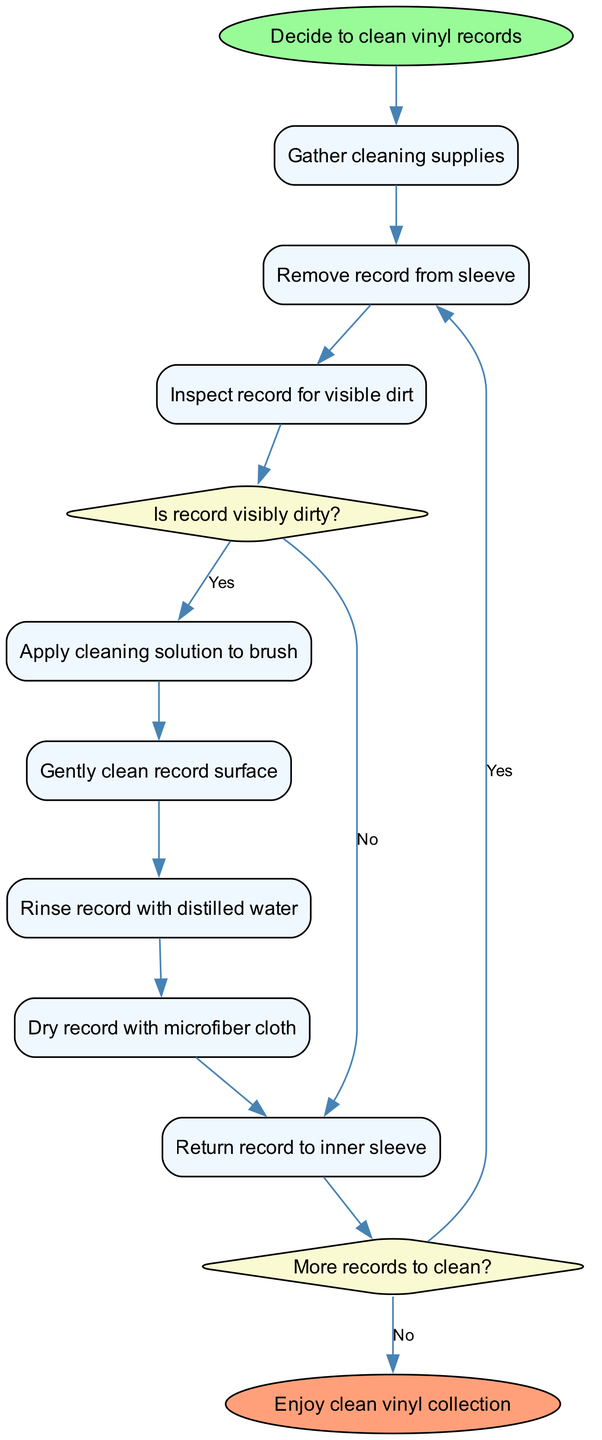What is the first activity in the diagram? The first node in the diagram lists "Gather cleaning supplies" as the initial activity after starting the cleaning process.
Answer: Gather cleaning supplies How many activities are there in total? Counting the listed activities, there are eight distinct activities depicted in the diagram, which includes both the cleaning and maintenance steps.
Answer: Eight What is the decision point related to visible dirt? The diagram highlights the condition "Is record visibly dirty?" as a decision point where actions diverge based on the presence of dirt on the record.
Answer: Is record visibly dirty? What action follows after noticing the record is not visibly dirty? According to the diagram, if the record is not visibly dirty, the next action is to "Return record to inner sleeve."
Answer: Return record to inner sleeve How do you proceed if there are more records to clean? If you encounter the decision point labeled "More records to clean?" and the answer is yes, the next step would be to "Remove record from sleeve," indicating continued cleaning efforts.
Answer: Remove record from sleeve What happens at the end of the cleaning process? The diagram indicates that after all cleaning and maintenance steps are completed, the final outcome is to "Enjoy clean vinyl collection."
Answer: Enjoy clean vinyl collection What is the last decision made in the process? The last decision made in the diagram is labeled "More records to clean?", which determines whether or not to continue to subsequent cleaning activities.
Answer: More records to clean? How do the activities connect to the end of the diagram? The series of activities connect logically such that once all the cleaning is done, and there are no more records to clean, the process culminates in the end node, "Enjoy clean vinyl collection."
Answer: Enjoy clean vinyl collection 